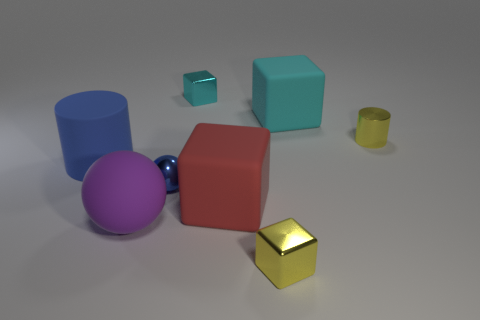Subtract all big cyan matte cubes. How many cubes are left? 3 Add 1 big objects. How many objects exist? 9 Subtract all red blocks. How many blocks are left? 3 Subtract 1 cubes. How many cubes are left? 3 Subtract all green blocks. Subtract all gray cylinders. How many blocks are left? 4 Subtract all small shiny things. Subtract all purple rubber things. How many objects are left? 3 Add 4 big purple balls. How many big purple balls are left? 5 Add 2 tiny gray balls. How many tiny gray balls exist? 2 Subtract 0 yellow spheres. How many objects are left? 8 Subtract all cylinders. How many objects are left? 6 